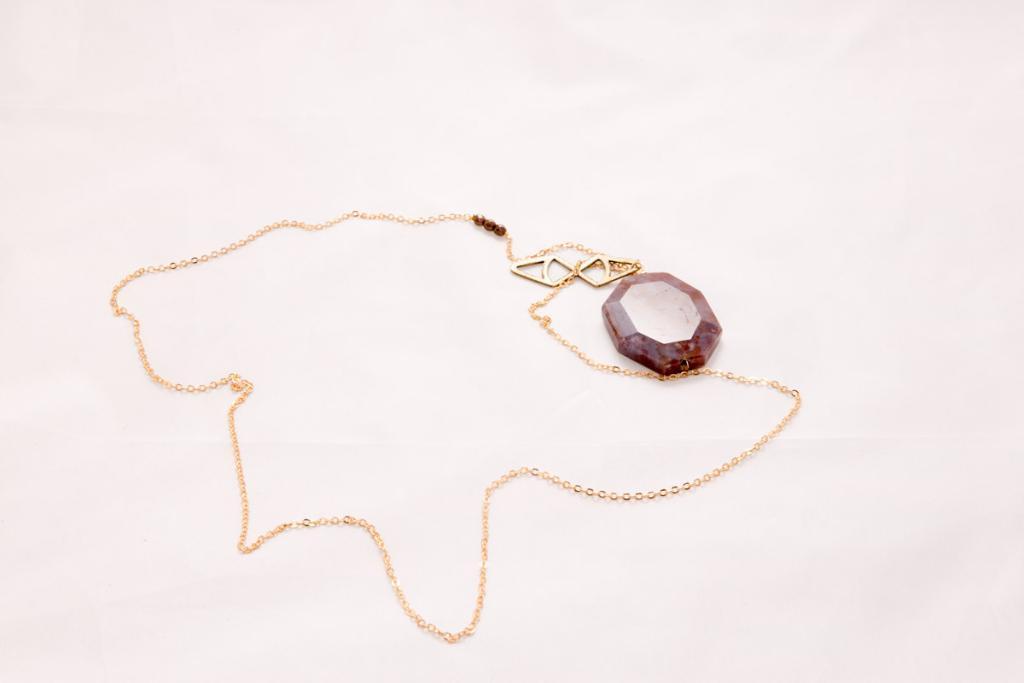Please provide a concise description of this image. In this image I can see a golden colour necklace on the white colour surface. 